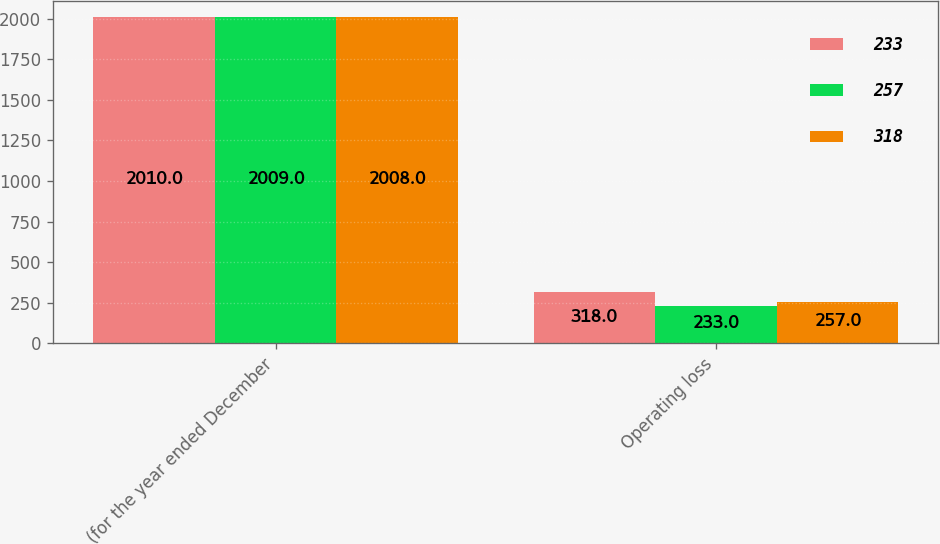Convert chart. <chart><loc_0><loc_0><loc_500><loc_500><stacked_bar_chart><ecel><fcel>(for the year ended December<fcel>Operating loss<nl><fcel>233<fcel>2010<fcel>318<nl><fcel>257<fcel>2009<fcel>233<nl><fcel>318<fcel>2008<fcel>257<nl></chart> 